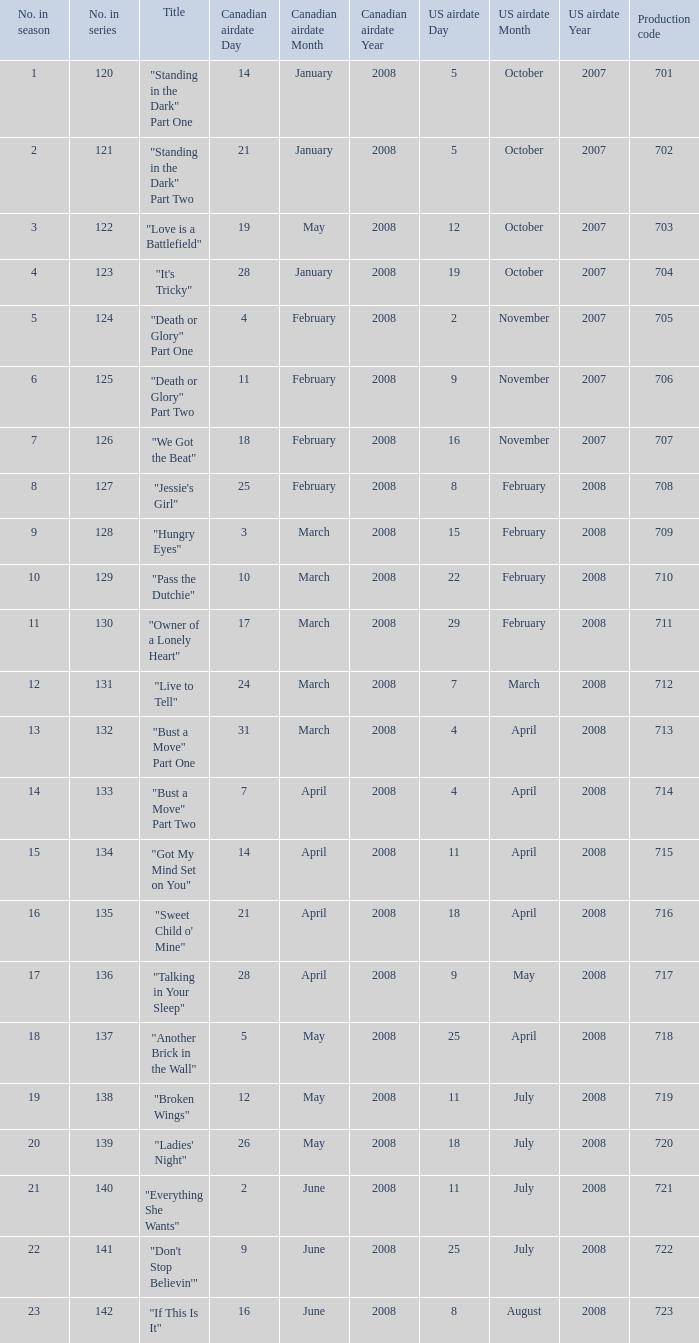The episode titled "don't stop believin'" was what highest number of the season? 22.0. 